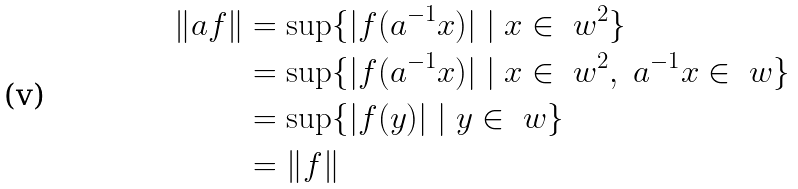Convert formula to latex. <formula><loc_0><loc_0><loc_500><loc_500>\| a f \| & = \sup \{ | f ( a ^ { - 1 } x ) | \ | \ x \in \ w ^ { 2 } \} \\ & = \sup \{ | f ( a ^ { - 1 } x ) | \ | \ x \in \ w ^ { 2 } , \ a ^ { - 1 } x \in \ w \} \\ & = \sup \{ | f ( y ) | \ | \ y \in \ w \} \\ & = \| f \| \\</formula> 